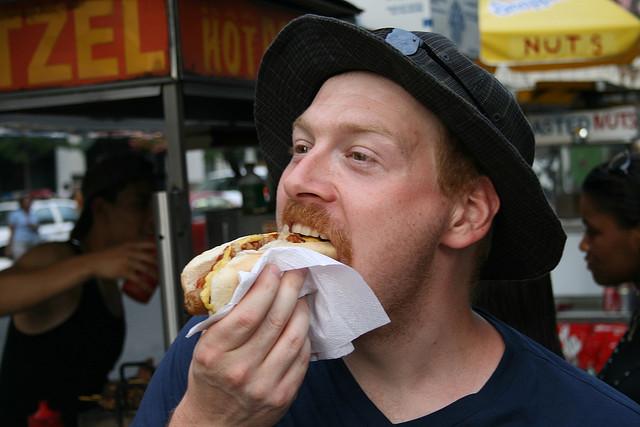Is the guy wearing a hat?
Give a very brief answer. Yes. Is he almost done eating that food?
Write a very short answer. No. Does this food look messy?
Quick response, please. Yes. What is wrapped around the sandwich?
Write a very short answer. Napkin. Is this person eating outdoors?
Concise answer only. Yes. What color is the man's hat?
Give a very brief answer. Black. What is the man eating?
Answer briefly. Hot dog. 